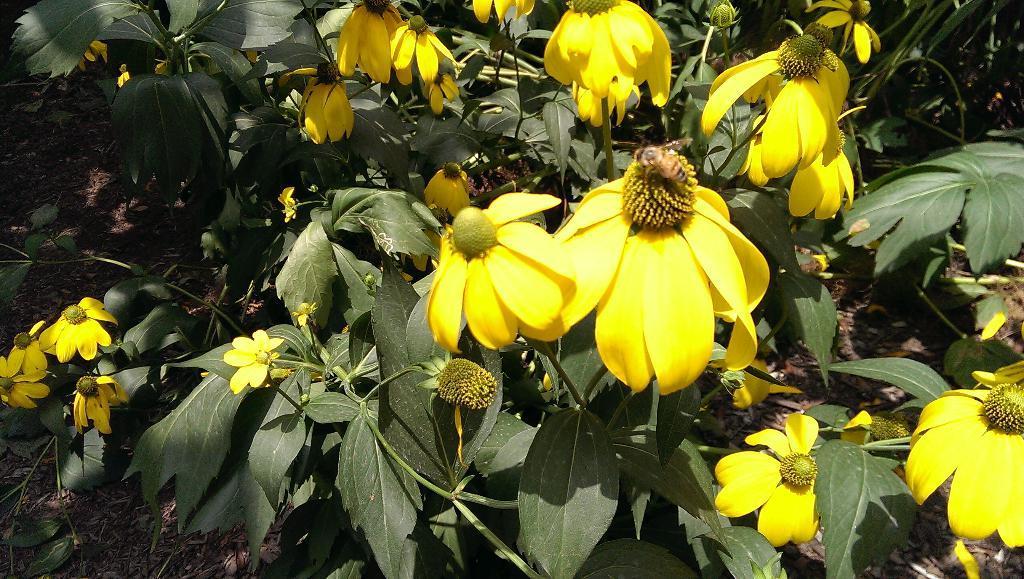Describe this image in one or two sentences. In this image I see number of plants and I see flowers on it which are of yellow in color and I see a insect over here and I see the ground. 